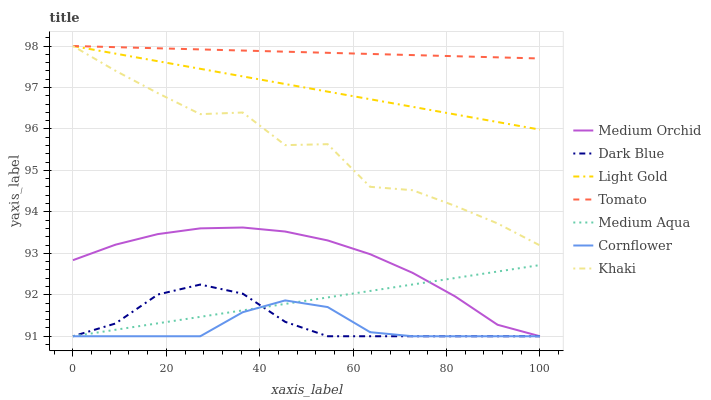Does Cornflower have the minimum area under the curve?
Answer yes or no. Yes. Does Tomato have the maximum area under the curve?
Answer yes or no. Yes. Does Khaki have the minimum area under the curve?
Answer yes or no. No. Does Khaki have the maximum area under the curve?
Answer yes or no. No. Is Medium Aqua the smoothest?
Answer yes or no. Yes. Is Khaki the roughest?
Answer yes or no. Yes. Is Cornflower the smoothest?
Answer yes or no. No. Is Cornflower the roughest?
Answer yes or no. No. Does Cornflower have the lowest value?
Answer yes or no. Yes. Does Khaki have the lowest value?
Answer yes or no. No. Does Light Gold have the highest value?
Answer yes or no. Yes. Does Cornflower have the highest value?
Answer yes or no. No. Is Dark Blue less than Tomato?
Answer yes or no. Yes. Is Tomato greater than Medium Aqua?
Answer yes or no. Yes. Does Cornflower intersect Dark Blue?
Answer yes or no. Yes. Is Cornflower less than Dark Blue?
Answer yes or no. No. Is Cornflower greater than Dark Blue?
Answer yes or no. No. Does Dark Blue intersect Tomato?
Answer yes or no. No. 